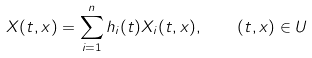<formula> <loc_0><loc_0><loc_500><loc_500>X ( t , x ) = \sum _ { i = 1 } ^ { n } h _ { i } ( t ) X _ { i } ( t , x ) , \quad ( t , x ) \in U</formula> 